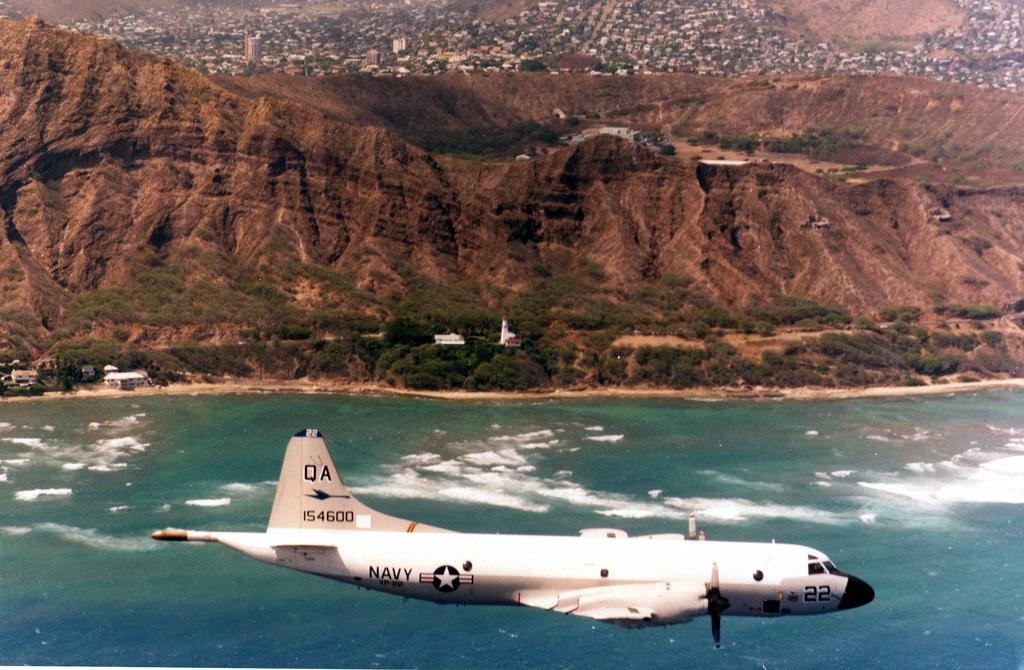What kind of plane is this?
Your answer should be compact. Navy. 